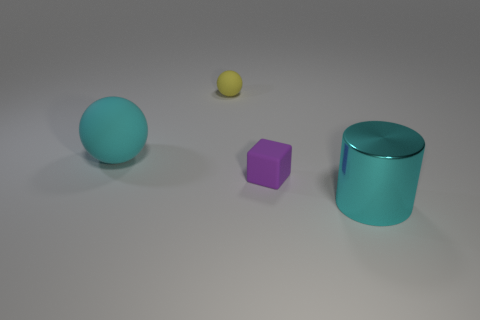There is a big ball that is the same color as the big metal object; what is it made of?
Give a very brief answer. Rubber. Is the material of the big cyan thing that is right of the tiny yellow thing the same as the purple block?
Offer a terse response. No. How many things are objects on the right side of the big ball or small rubber spheres?
Your response must be concise. 3. There is a big ball that is made of the same material as the small purple object; what is its color?
Offer a terse response. Cyan. Are there any spheres that have the same size as the cyan rubber thing?
Ensure brevity in your answer.  No. Does the matte thing that is behind the big cyan sphere have the same color as the rubber block?
Provide a succinct answer. No. The thing that is both left of the purple object and to the right of the cyan rubber ball is what color?
Provide a short and direct response. Yellow. There is a cyan object that is the same size as the cyan metal cylinder; what is its shape?
Your answer should be very brief. Sphere. Is there another cyan metal object of the same shape as the cyan metallic thing?
Offer a terse response. No. There is a cyan object that is in front of the cube; is its size the same as the tiny purple thing?
Make the answer very short. No. 